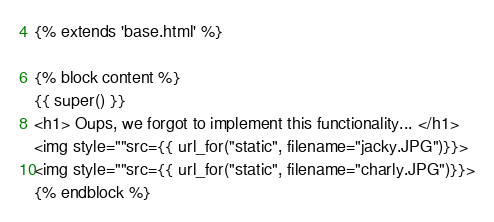<code> <loc_0><loc_0><loc_500><loc_500><_HTML_>{% extends 'base.html' %}

{% block content %}
{{ super() }}
<h1> Oups, we forgot to implement this functionality... </h1>
<img style=""src={{ url_for("static", filename="jacky.JPG")}}>
<img style=""src={{ url_for("static", filename="charly.JPG")}}>
{% endblock %}
</code> 